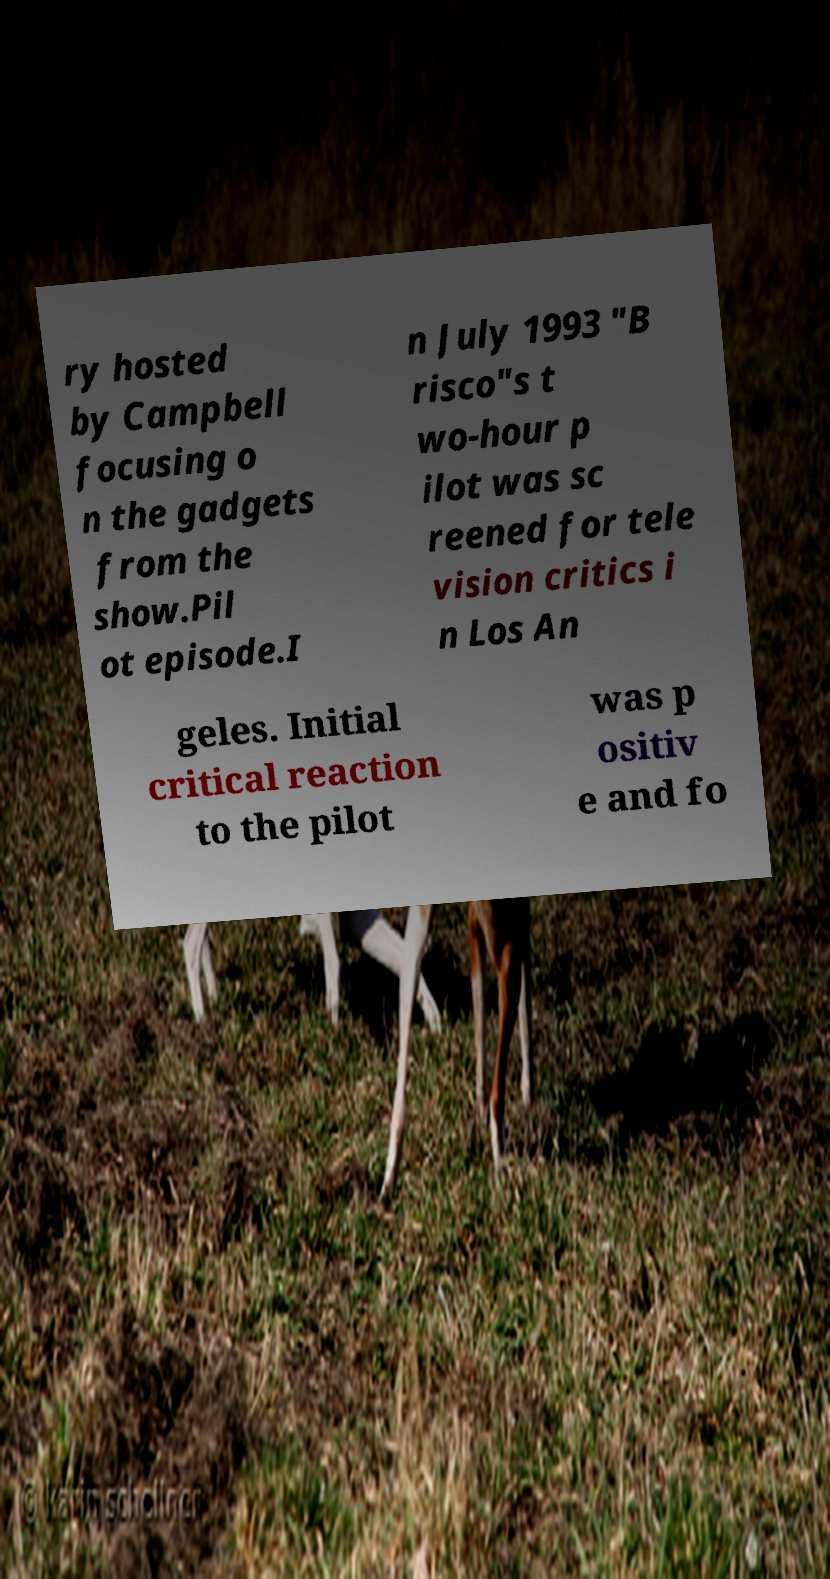For documentation purposes, I need the text within this image transcribed. Could you provide that? ry hosted by Campbell focusing o n the gadgets from the show.Pil ot episode.I n July 1993 "B risco"s t wo-hour p ilot was sc reened for tele vision critics i n Los An geles. Initial critical reaction to the pilot was p ositiv e and fo 